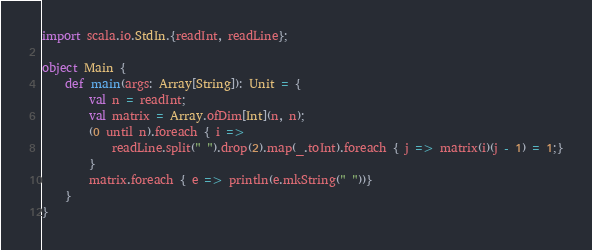<code> <loc_0><loc_0><loc_500><loc_500><_Scala_>import scala.io.StdIn.{readInt, readLine};

object Main {
    def main(args: Array[String]): Unit = {
        val n = readInt;
        val matrix = Array.ofDim[Int](n, n);
        (0 until n).foreach { i =>
            readLine.split(" ").drop(2).map(_.toInt).foreach { j => matrix(i)(j - 1) = 1;}
        }
        matrix.foreach { e => println(e.mkString(" "))}
    }
}
</code> 